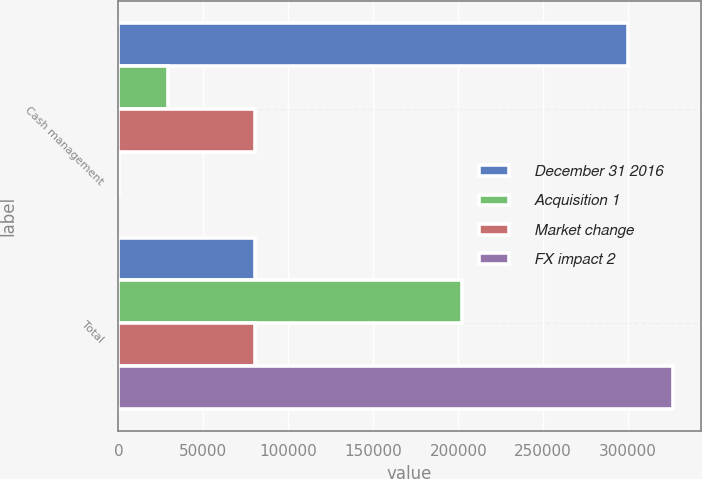Convert chart. <chart><loc_0><loc_0><loc_500><loc_500><stacked_bar_chart><ecel><fcel>Cash management<fcel>Total<nl><fcel>December 31 2016<fcel>299884<fcel>80635<nl><fcel>Acquisition 1<fcel>29228<fcel>202191<nl><fcel>Market change<fcel>80635<fcel>80635<nl><fcel>FX impact 2<fcel>430<fcel>326364<nl></chart> 